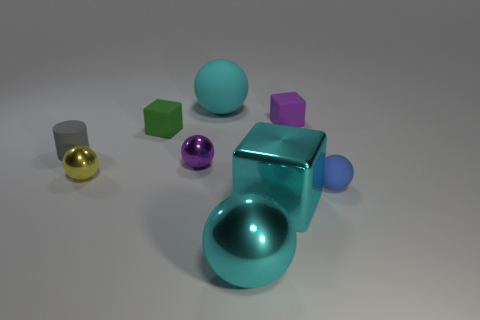How big is the cyan sphere that is behind the tiny gray rubber object?
Keep it short and to the point. Large. There is a large cyan object that is both on the left side of the cyan metallic block and in front of the big rubber object; what is its shape?
Provide a succinct answer. Sphere. There is a purple thing that is the same shape as the small green matte thing; what is its size?
Provide a short and direct response. Small. What number of other gray cylinders are the same material as the gray cylinder?
Give a very brief answer. 0. Do the big matte sphere and the big ball in front of the tiny gray rubber cylinder have the same color?
Give a very brief answer. Yes. Is the number of tiny matte things greater than the number of small blue spheres?
Provide a succinct answer. Yes. The cylinder has what color?
Provide a succinct answer. Gray. Is the color of the cube in front of the tiny gray rubber thing the same as the big matte object?
Keep it short and to the point. Yes. What is the material of the block that is the same color as the large rubber ball?
Make the answer very short. Metal. How many small matte blocks are the same color as the metal block?
Your response must be concise. 0. 